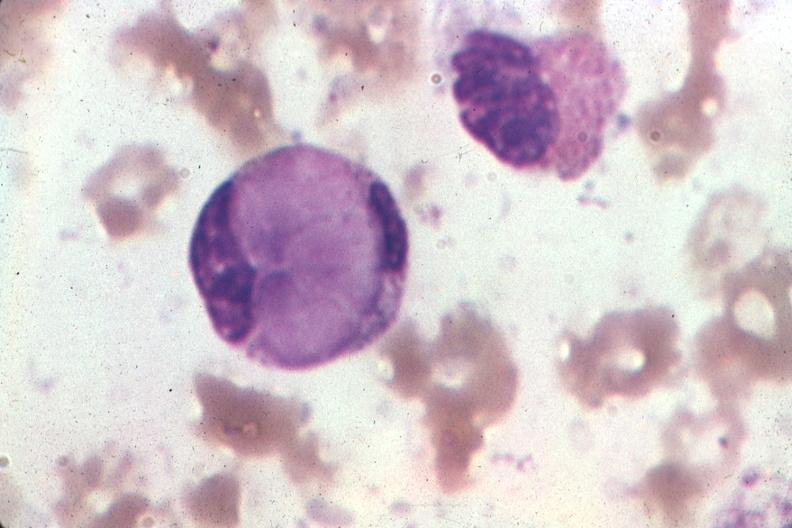does this image show wrights very good example?
Answer the question using a single word or phrase. Yes 